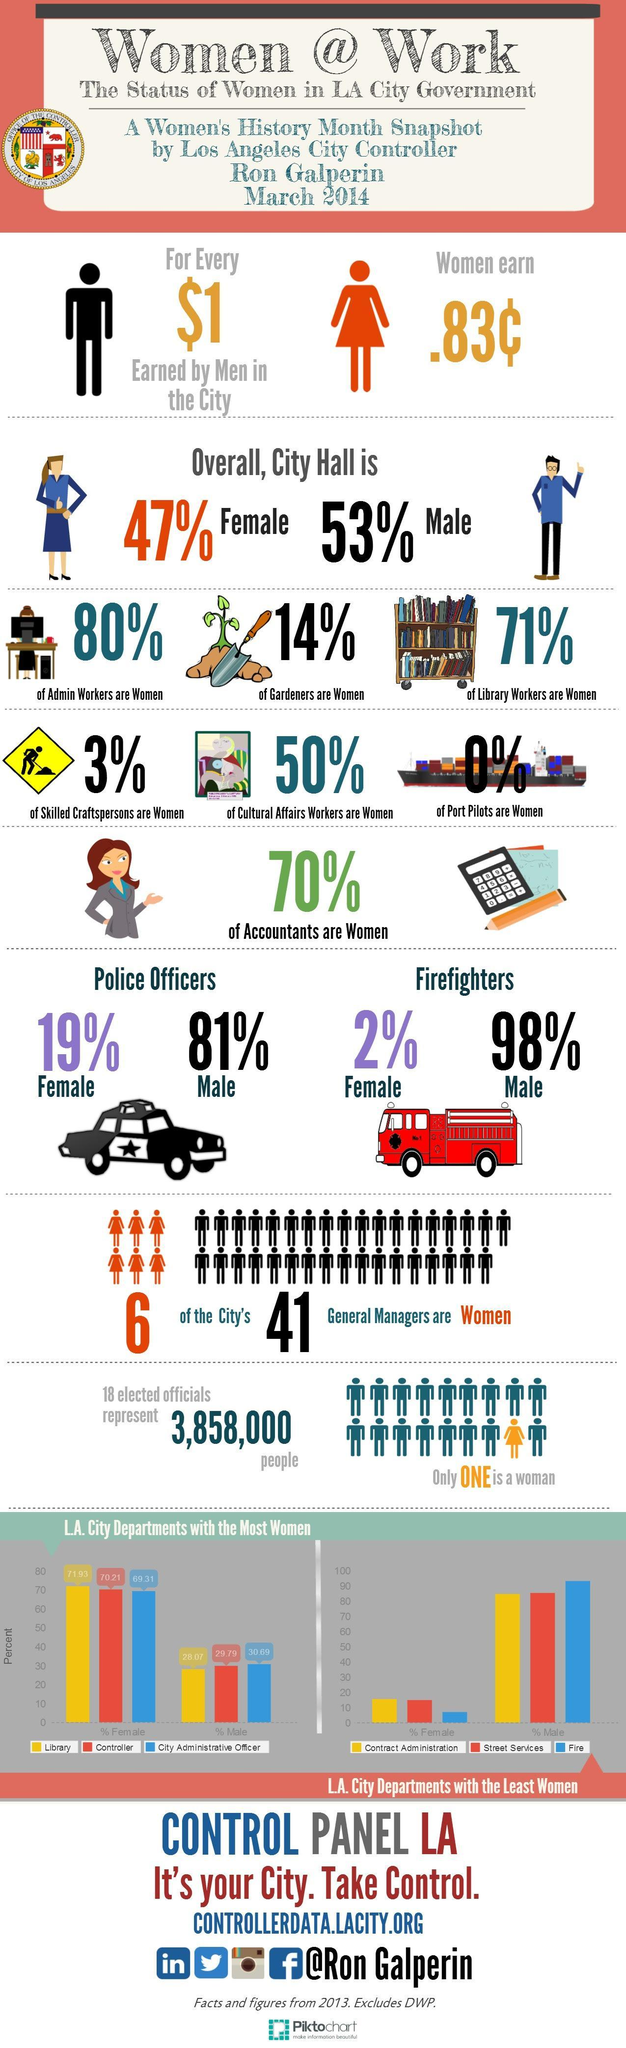What is the gender gap percent among men and women as controller from the bar graph?
Answer the question with a short phrase. 40.42% What percent of men are port pilots? 100% Which occupation has equal contributions by men and women in City Hall? Cultural Affairs Workers What percent of males work as city administrative officer? 30.69% What is the gender gap among Police officers? 62% Which occupation does not have presence of women in City Hall? Port Pilots Which gender has more population in City Hall? Male What percent of accountants are men? 30% From the graph, what percent of women work in libraries? 71.93% 